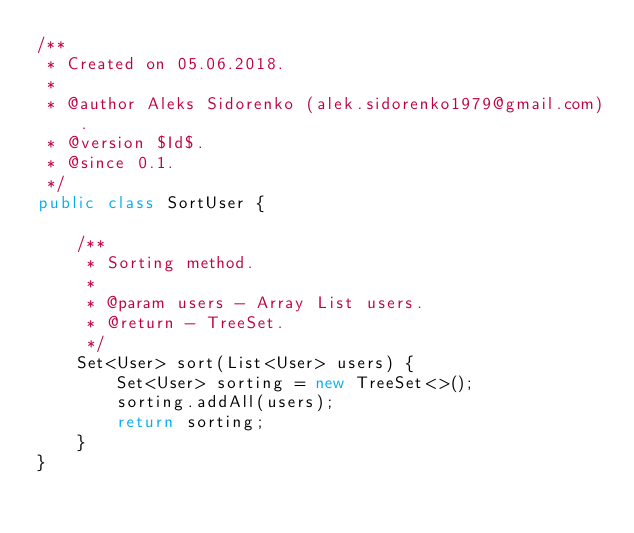<code> <loc_0><loc_0><loc_500><loc_500><_Java_>/**
 * Created on 05.06.2018.
 *
 * @author Aleks Sidorenko (alek.sidorenko1979@gmail.com).
 * @version $Id$.
 * @since 0.1.
 */
public class SortUser {

    /**
     * Sorting method.
     *
     * @param users - Array List users.
     * @return - TreeSet.
     */
    Set<User> sort(List<User> users) {
        Set<User> sorting = new TreeSet<>();
        sorting.addAll(users);
        return sorting;
    }
}
</code> 